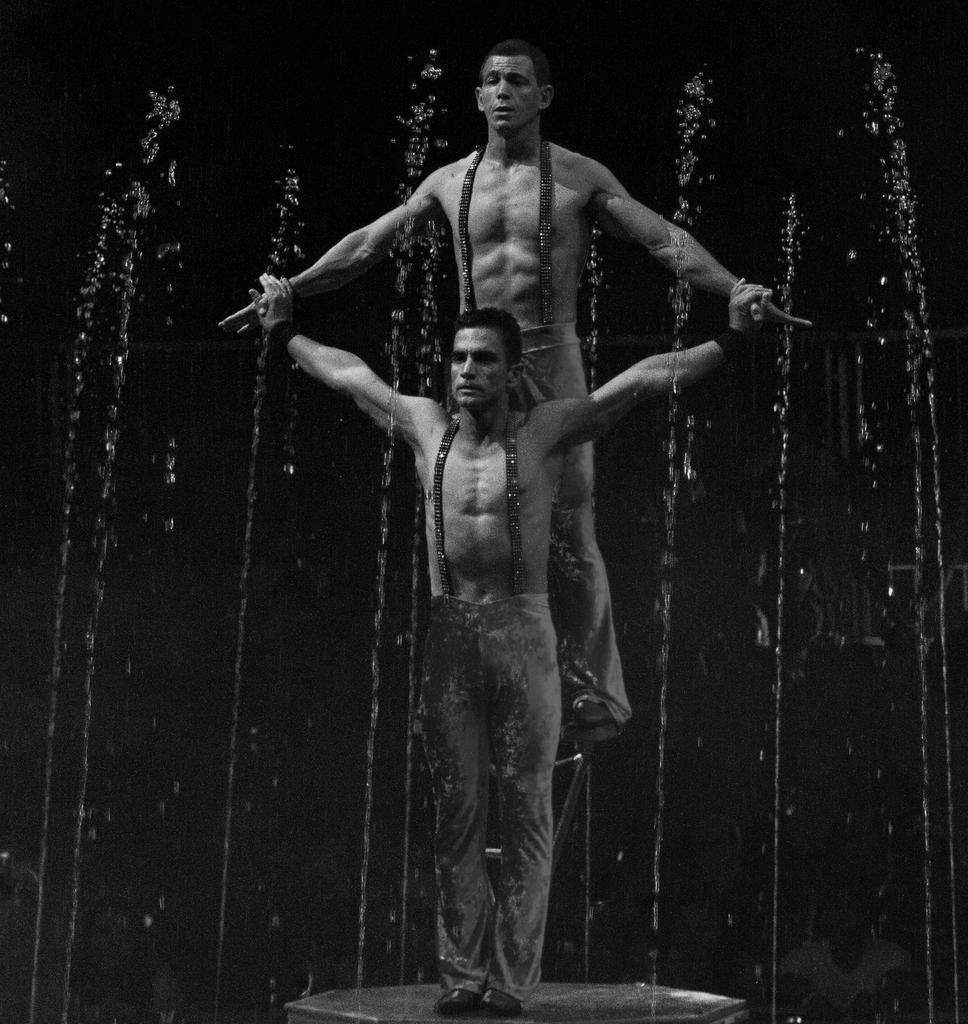How many people are present in the image? There are two people in the image. What are the positions of the two people in the image? One person is standing on the surface, while the other person is standing on a ladder. What can be seen in the background of the image? There is water sprinkling in the background of the image. How does the cream affect the texture of the ladder in the image? There is no cream present in the image, so it cannot affect the texture of the ladder. 